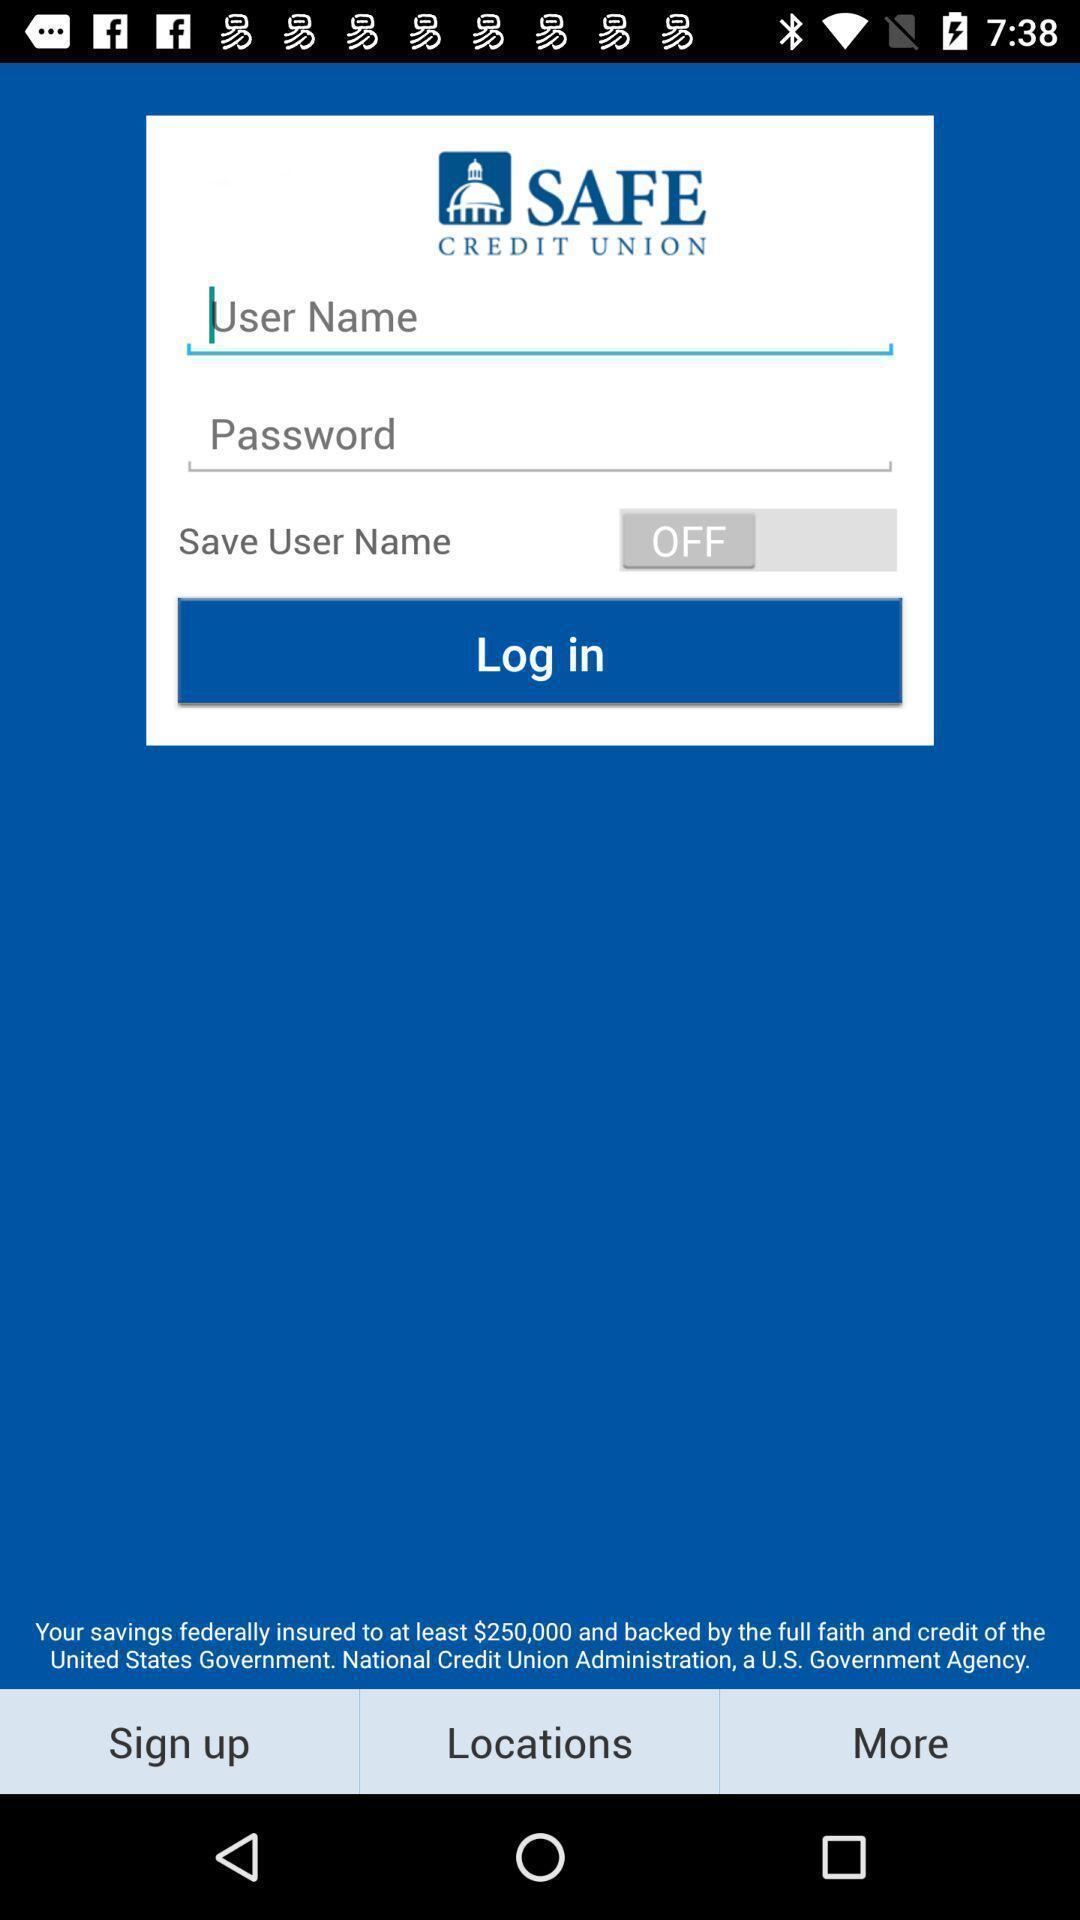What can you discern from this picture? Page displaying to login of an banking application. 